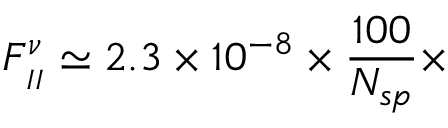<formula> <loc_0><loc_0><loc_500><loc_500>F _ { _ { I I } } ^ { \nu } \simeq 2 . 3 \times 1 0 ^ { - 8 } \times \frac { 1 0 0 } { N _ { s p } } \times</formula> 